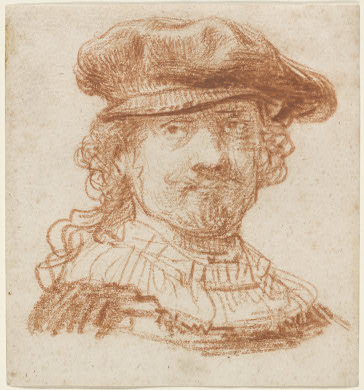Can you provide some historical context about the time period this artwork might belong to? This artwork belongs to the Baroque period, which spanned from the early 17th century to the mid-18th century. The Baroque era is characterized by its ornate detail, dramatic expression, and bold use of color and shadow (chiaroscuro). Artists from this period sought to evoke emotion and passion, often depicting scenes with intense movement and clear, detailed realism. The use of red chalk and the emphasis on texture and depth in this portrait are hallmark techniques of Baroque art, which aimed to bridge the gap between the viewer and the subject through vivid, lifelike representation. 